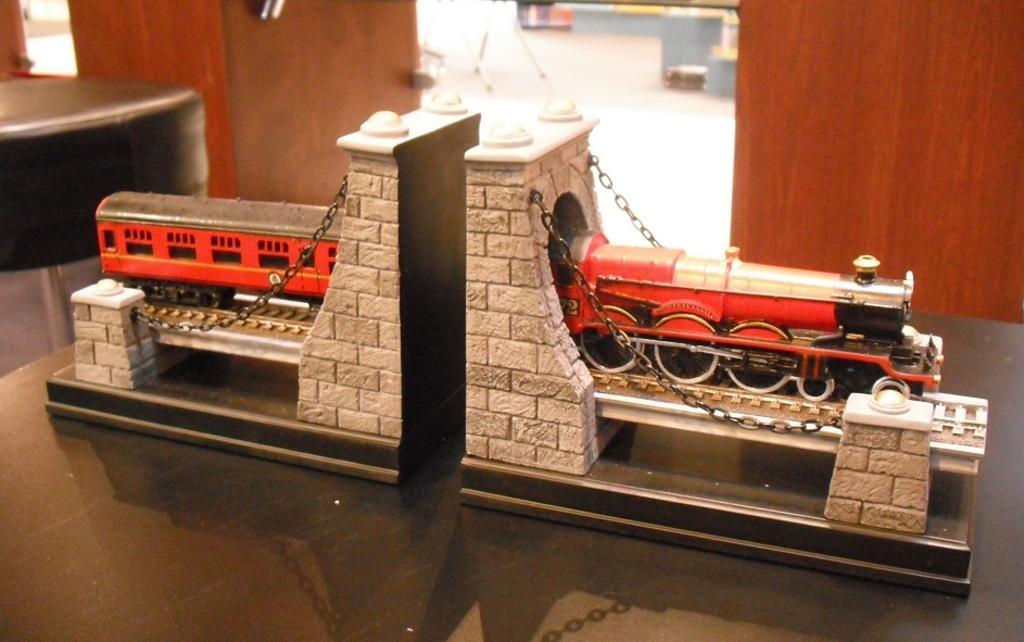How would you summarize this image in a sentence or two? In this picture I can see a toy of a train and bridge which is placed on the table, side we can see chair and also we can see wooden thing. 